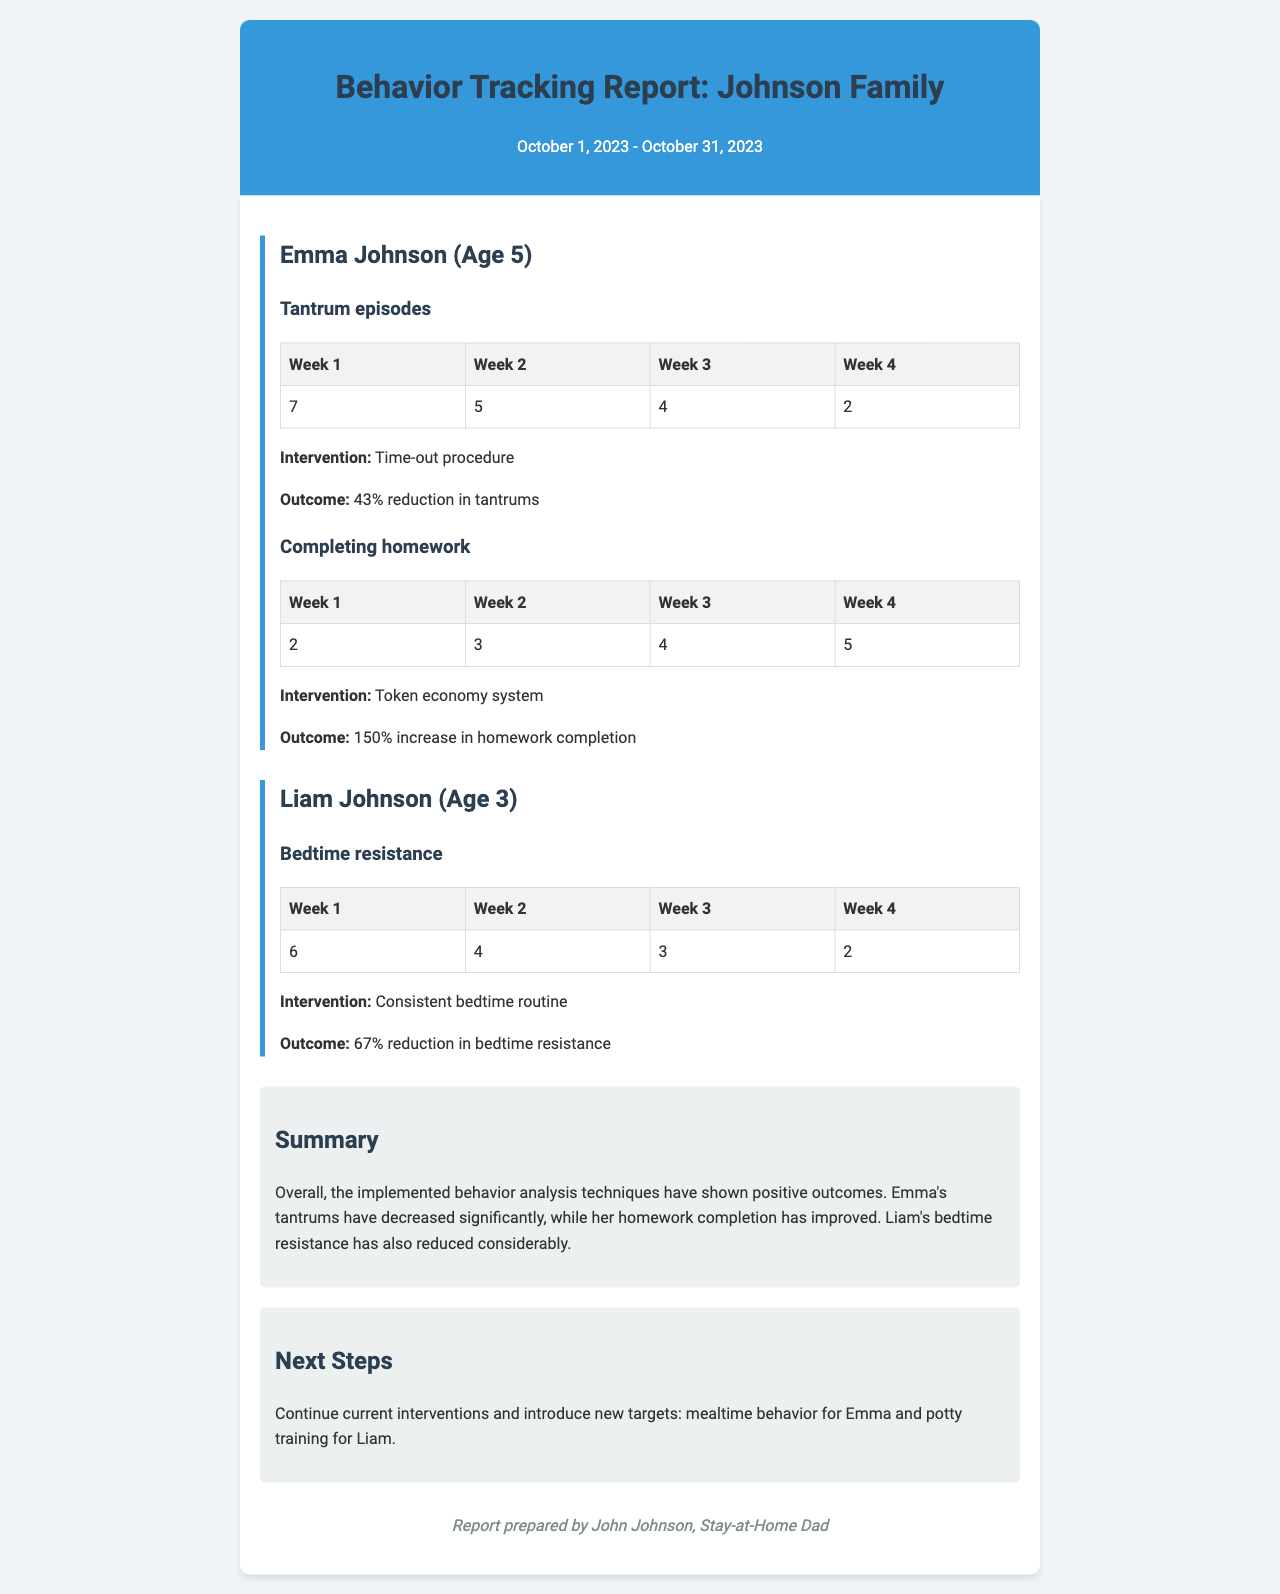What is the age of Emma Johnson? Emma Johnson's age is mentioned in the document.
Answer: 5 How many tantrum episodes did Emma have in Week 3? The document provides a table showing tantrum episodes for each week.
Answer: 4 What type of intervention was used for Liam's bedtime resistance? The intervention for Liam's bedtime resistance is specified in the report.
Answer: Consistent bedtime routine What was the percentage reduction in tantrums for Emma? The document states the outcome of the intervention for Emma's tantrums.
Answer: 43% How many homework assignments did Emma complete in Week 4? The data in the table shows the number of homework assignments for each week.
Answer: 5 What is the total number of bedtime resistance episodes for Liam in Week 1? The report lists Liam's bedtime resistance episodes for each week in a table.
Answer: 6 Which behavior showed a 150% increase? The document highlights an intervention outcome that resulted in a significant increase.
Answer: Completing homework What is the summary of the behavior analysis outcomes? The summary section provides an overall assessment of the interventions' effectiveness.
Answer: Positive outcomes What are the next steps mentioned in the report? The next steps section outlines the proposed future interventions for the children.
Answer: Continue current interventions and introduce new targets 